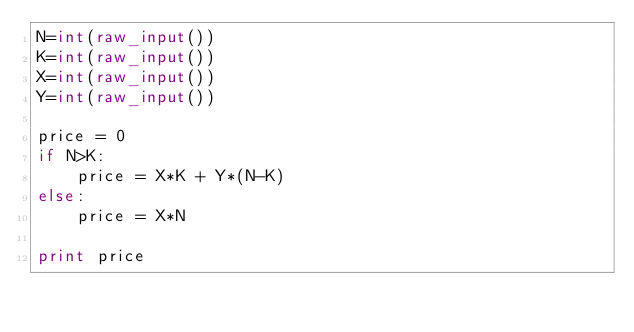<code> <loc_0><loc_0><loc_500><loc_500><_Python_>N=int(raw_input())
K=int(raw_input())
X=int(raw_input())
Y=int(raw_input())

price = 0
if N>K:
    price = X*K + Y*(N-K)
else:
    price = X*N

print price

</code> 